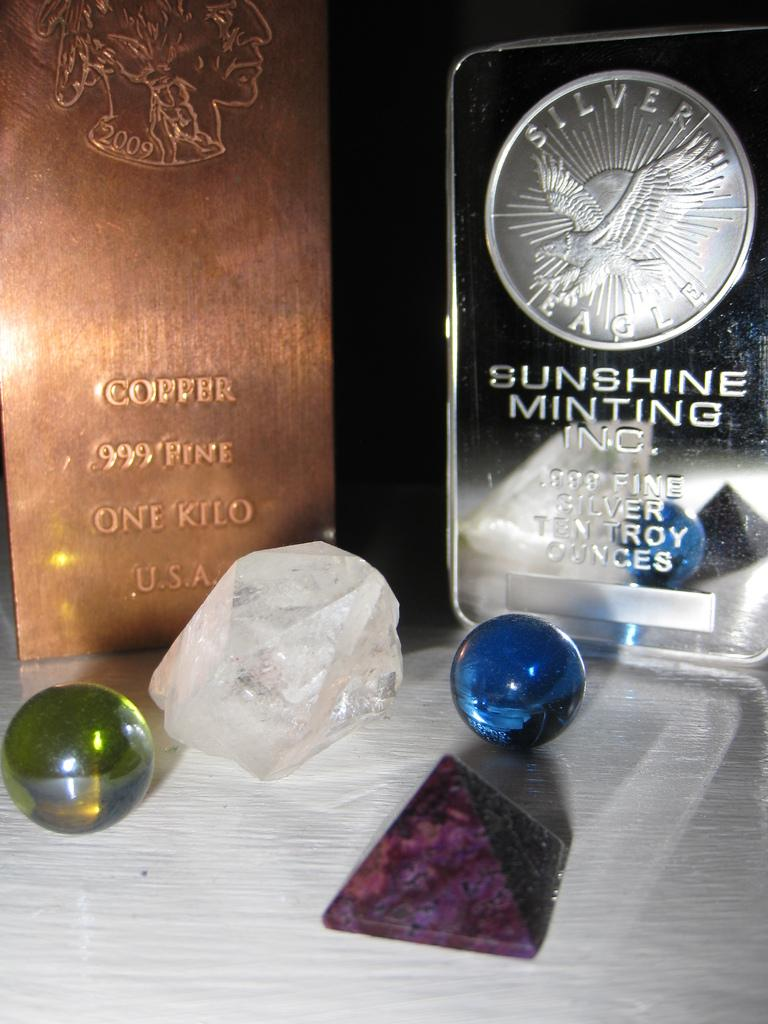Provide a one-sentence caption for the provided image. Some marbles and crystals are displayed in front of a Sunshine Minting coin. 